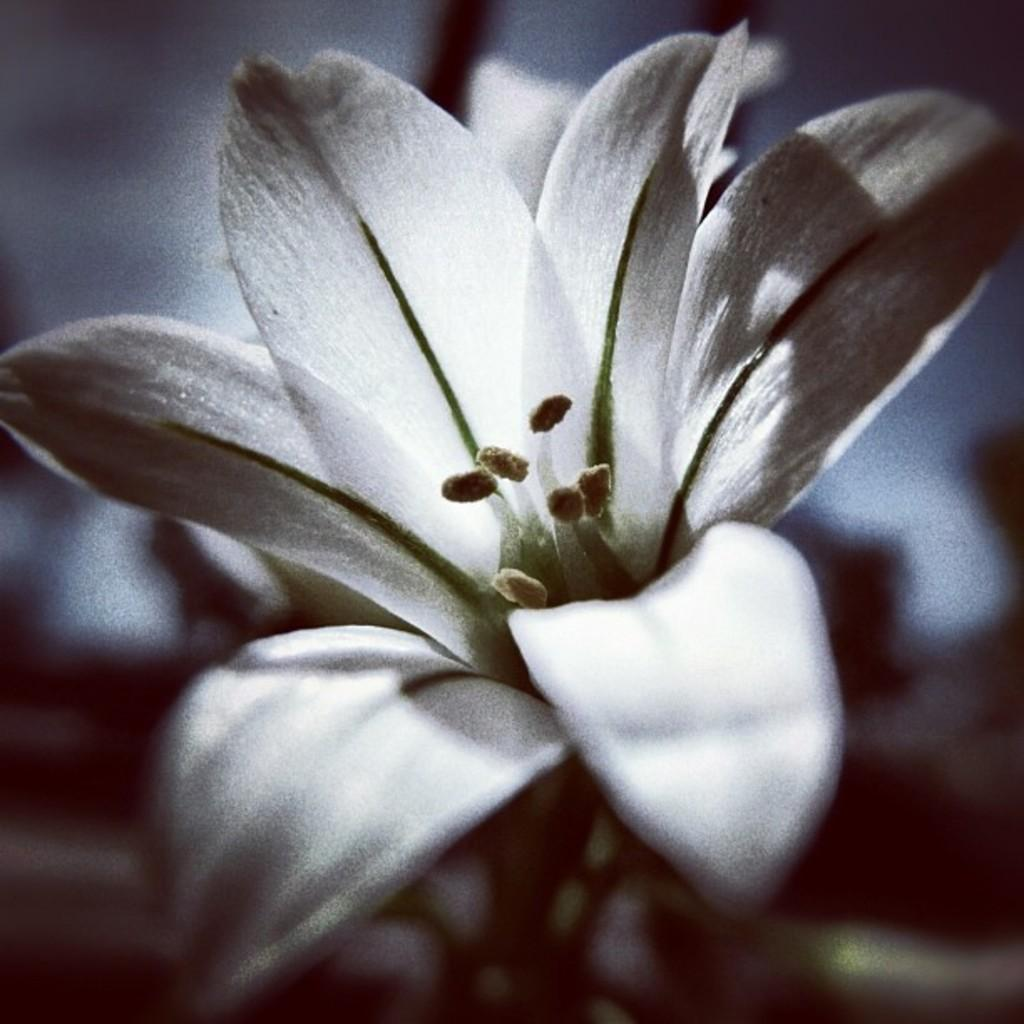What is the main subject of the image? There is a flower in the image. Can you describe the background of the image? The background of the image is blurred. Is the flower crying in the image? No, the flower is not crying in the image; it is a still image of a flower. What type of brush is being used to paint the flower in the image? There is no brush or painting activity depicted in the image; it is a photograph of a flower. 